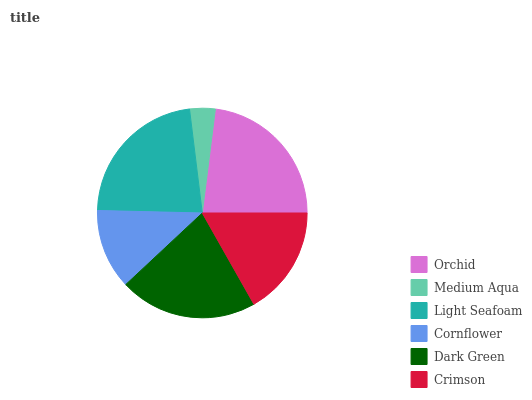Is Medium Aqua the minimum?
Answer yes or no. Yes. Is Orchid the maximum?
Answer yes or no. Yes. Is Light Seafoam the minimum?
Answer yes or no. No. Is Light Seafoam the maximum?
Answer yes or no. No. Is Light Seafoam greater than Medium Aqua?
Answer yes or no. Yes. Is Medium Aqua less than Light Seafoam?
Answer yes or no. Yes. Is Medium Aqua greater than Light Seafoam?
Answer yes or no. No. Is Light Seafoam less than Medium Aqua?
Answer yes or no. No. Is Dark Green the high median?
Answer yes or no. Yes. Is Crimson the low median?
Answer yes or no. Yes. Is Medium Aqua the high median?
Answer yes or no. No. Is Orchid the low median?
Answer yes or no. No. 